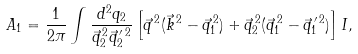<formula> <loc_0><loc_0><loc_500><loc_500>A _ { 1 } = \frac { 1 } { 2 \pi } \int \frac { d ^ { 2 } q _ { 2 } } { \vec { q } _ { 2 } ^ { \, 2 } \vec { q } _ { 2 } ^ { \, \prime \, 2 } } \left [ \vec { q } ^ { \, 2 } ( \vec { k } ^ { \, 2 } - \vec { q } _ { 1 } ^ { \, 2 } ) + \vec { q } _ { 2 } ^ { \, 2 } ( \vec { q } _ { 1 } ^ { \, 2 } - \vec { q } _ { 1 } ^ { \, \prime \, 2 } ) \right ] I ,</formula> 